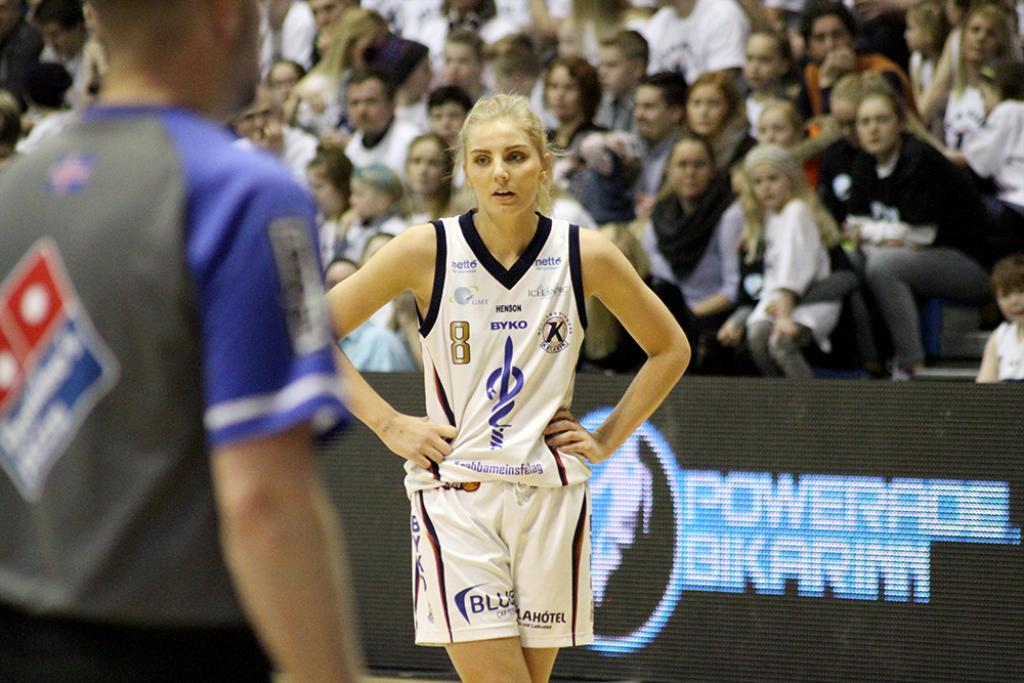Provide a one-sentence caption for the provided image. Blonde woman playing basketball in a jersey featuring a host of ads such as "Blue". 